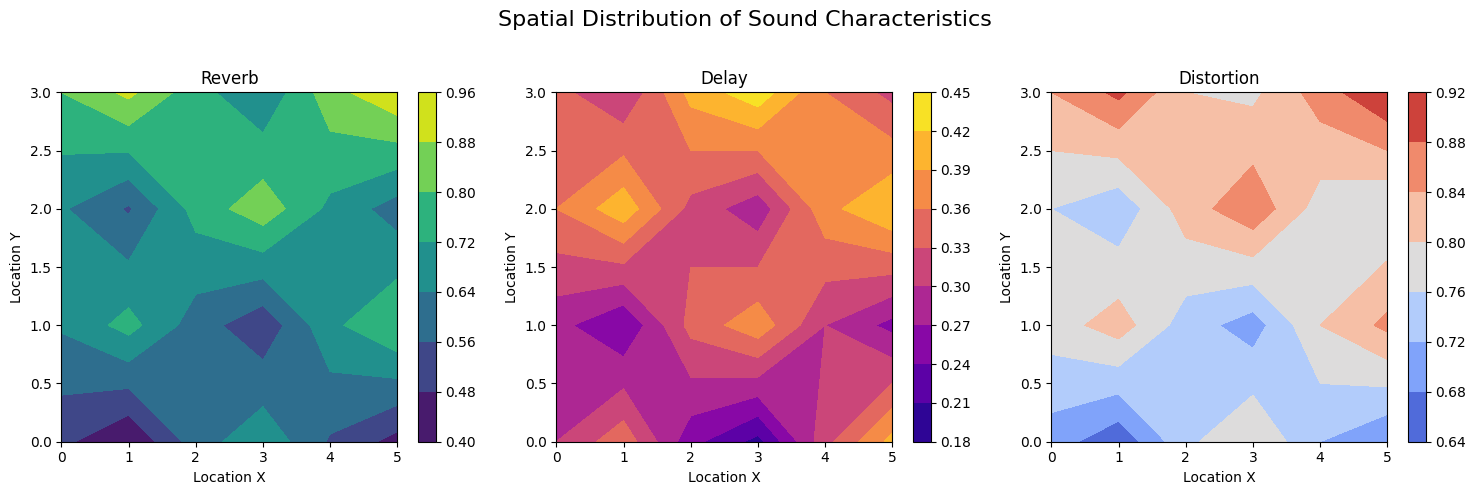What are the maximum values of reverb, delay, and distortion? Inspect the contour plots for each sound characteristic. The highest value corresponds to the darkest or most intense color in the respective plots. For reverb, the maximum value is 0.95 found at location (5, 3). For delay, the maximum value is 0.44 found at location (5, 1). For distortion, the maximum value is 0.92 found at location (5, 3).
Answer: Reverb: 0.95, Delay: 0.44, Distortion: 0.92 Which location has the highest combined sound characteristic (sum of reverb, delay, and distortion)? To find this, sum the values of reverb, delay, and distortion at each location. The location with the highest sum is (5, 3) with a combined value of 0.95 + 0.32 + 0.92 = 2.19.
Answer: (5, 3) What is the average reverb value across all locations? Sum all the reverb values and divide by the number of locations (6 * 4 = 24). The sum of reverb values is 14.7, so the average is 14.7 / 24 ≈ 0.6125.
Answer: 0.6125 Which sound characteristic shows the most variation across different locations? Compare the range of values (max - min) for each characteristic. Reverb ranges from 0.4 to 0.95, Delay from 0.2 to 0.44, and Distortion from 0.65 to 0.92. Reverb has the largest range (0.95 - 0.4 = 0.55), indicating the most variation.
Answer: Reverb How does the distortion value change along the y-axis from y=0 to y=3 at x=2? Examine the distortion plot at locations (2,0), (2,1), (2,2), and (2,3). The distortion values are 0.74, 0.7, 0.8, and 0.85, respectively, indicating an increasing trend.
Answer: Increases Where is the lowest value of delay located? Inspect the delay contour plot for the lightest color. The lowest value is 0.2, found at location (0, 3).
Answer: (0, 3) Compare the reverb values at locations (0,0) and (5,0). Which location has a higher value and by how much? At (0,0), reverb is 0.5, and at (5,0), it is 0.75. The difference is 0.75 - 0.5 = 0.25. Location (5,0) has a higher value by 0.25.
Answer: (5,0) by 0.25 Which location has the most balanced sound profile (least difference between the maximum and minimum of reverb, delay, and distortion)? Compute the range (max - min) for each sound characteristic at each location and identify the location with the smallest range. For instance, at (1,1), the values are reverb: 0.45, delay: 0.4, distortion: 0.68. The range is max(0.45, 0.4, 0.68) - min(0.45, 0.4, 0.68) = 0.28. Location (2,1) has the smallest range of 0.12.
Answer: (2,1) 